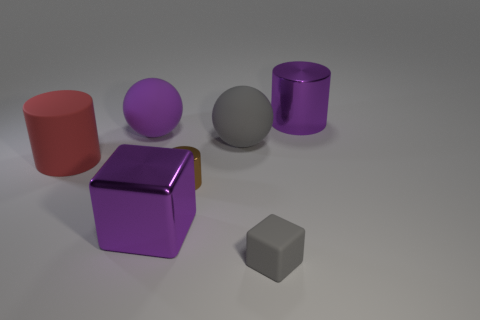What is the shape of the large purple metal thing that is in front of the large matte ball to the right of the purple shiny object that is in front of the small shiny object?
Offer a very short reply. Cube. There is a rubber thing that is the same color as the small block; what shape is it?
Make the answer very short. Sphere. The cylinder that is on the left side of the large gray sphere and on the right side of the red cylinder is made of what material?
Your answer should be very brief. Metal. Are there fewer small brown things than tiny yellow blocks?
Your response must be concise. No. There is a large red rubber object; does it have the same shape as the large purple metal object that is on the right side of the tiny gray block?
Your answer should be very brief. Yes. There is a purple metallic object that is to the left of the purple cylinder; is its size the same as the tiny metal thing?
Your answer should be very brief. No. There is a purple matte thing that is the same size as the gray rubber sphere; what is its shape?
Provide a succinct answer. Sphere. Is the shape of the large gray thing the same as the red object?
Give a very brief answer. No. How many large red objects are the same shape as the small metallic thing?
Your response must be concise. 1. How many metallic things are behind the large gray sphere?
Keep it short and to the point. 1. 